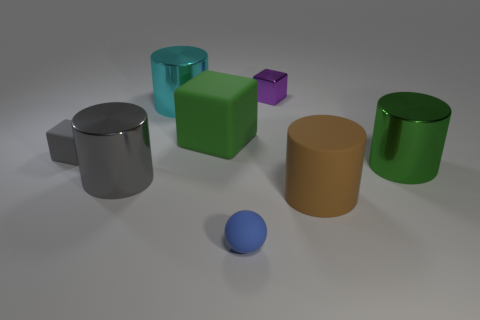Add 2 tiny gray rubber blocks. How many objects exist? 10 Subtract all cubes. How many objects are left? 5 Subtract all brown rubber objects. Subtract all gray metal cylinders. How many objects are left? 6 Add 3 gray matte cubes. How many gray matte cubes are left? 4 Add 5 tiny matte blocks. How many tiny matte blocks exist? 6 Subtract 0 gray balls. How many objects are left? 8 